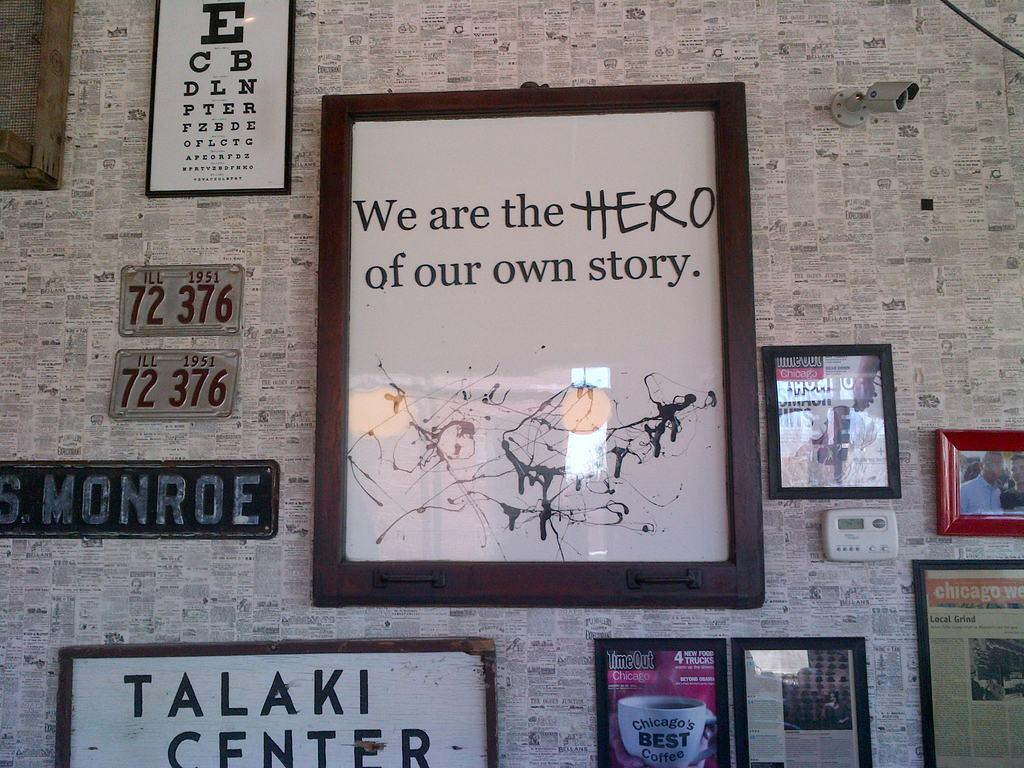Provide a one-sentence caption for the provided image. lots pictures hung on the wall one says we are the hero. 